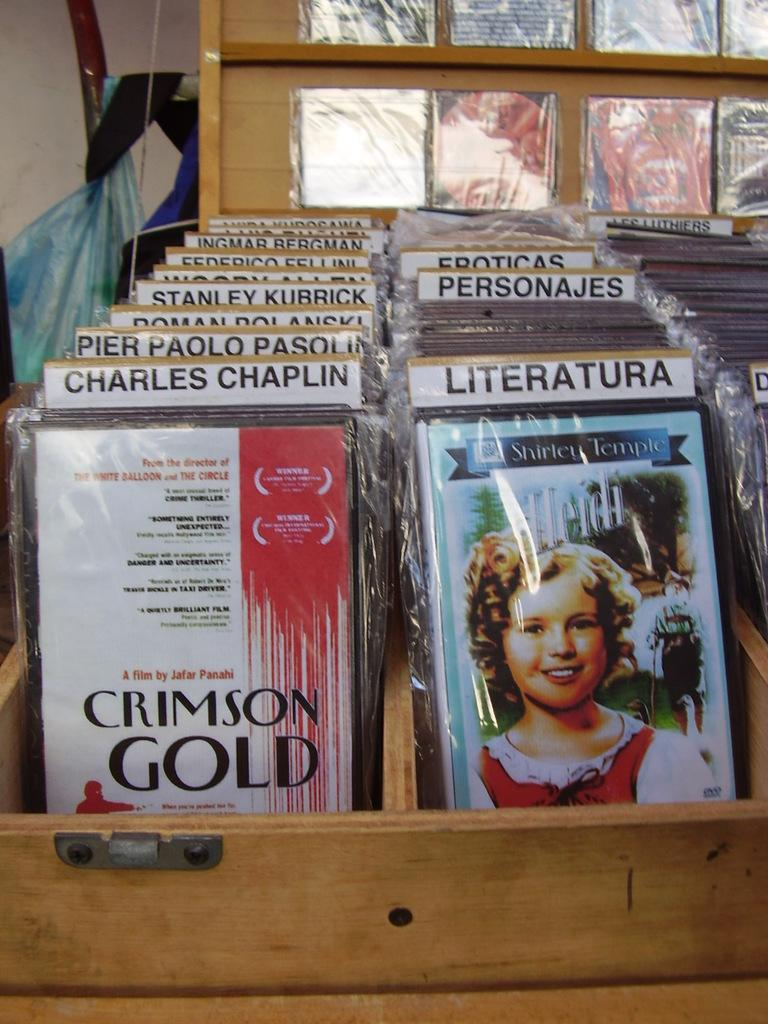What objects are visible in the image? There are books in the image. Where are the books placed? The books are placed on wooden boxes. What type of neck can be seen on the books in the image? There is no neck present on the books in the image, as books do not have necks. 